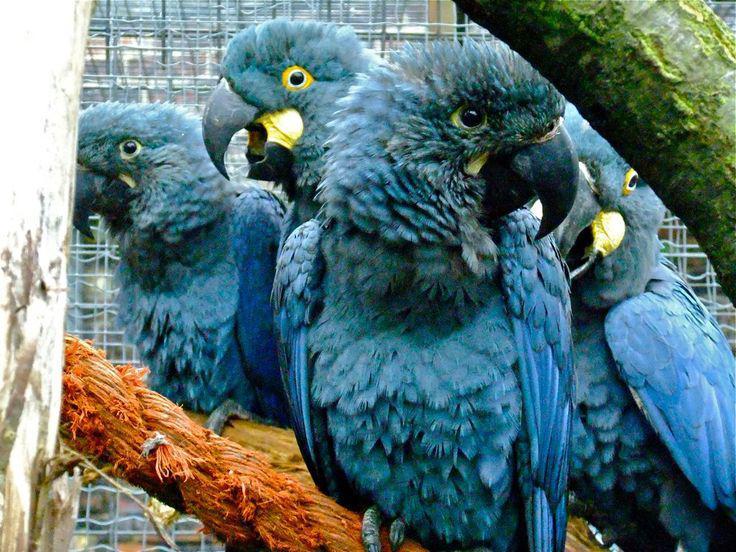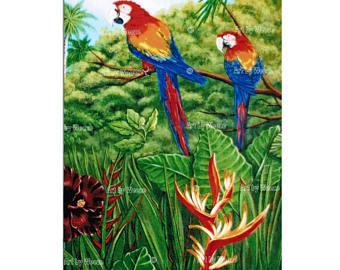The first image is the image on the left, the second image is the image on the right. Assess this claim about the two images: "There are exactly two birds in the image on the right.". Correct or not? Answer yes or no. Yes. 